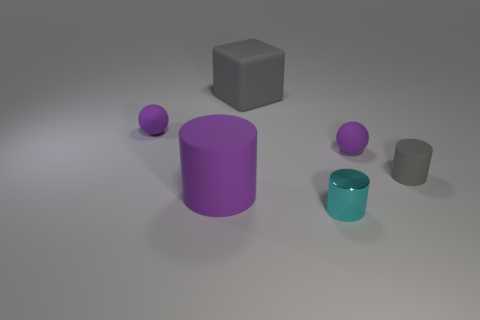Is there any other thing that is the same size as the purple cylinder?
Give a very brief answer. Yes. What is the shape of the gray matte thing behind the tiny purple object that is on the left side of the large purple cylinder?
Make the answer very short. Cube. Is the material of the tiny cylinder that is in front of the big purple cylinder the same as the purple ball to the right of the block?
Give a very brief answer. No. What number of cyan things are on the right side of the small thing that is in front of the small gray object?
Provide a short and direct response. 0. Does the gray rubber object left of the gray matte cylinder have the same shape as the small thing that is left of the big gray matte thing?
Ensure brevity in your answer.  No. There is a purple rubber thing that is behind the big purple object and left of the gray cube; what size is it?
Keep it short and to the point. Small. What color is the large rubber thing that is the same shape as the small cyan metallic thing?
Provide a short and direct response. Purple. What is the color of the tiny ball that is right of the rubber thing that is to the left of the large purple cylinder?
Your answer should be very brief. Purple. What is the shape of the tiny gray thing?
Ensure brevity in your answer.  Cylinder. There is a rubber thing that is both on the left side of the tiny cyan shiny thing and to the right of the big purple cylinder; what is its shape?
Give a very brief answer. Cube. 